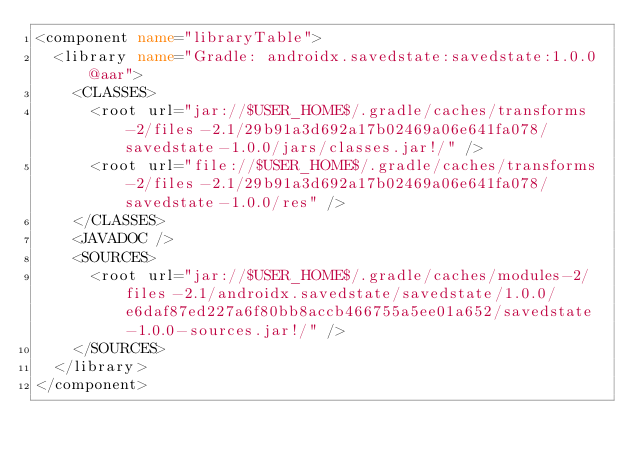<code> <loc_0><loc_0><loc_500><loc_500><_XML_><component name="libraryTable">
  <library name="Gradle: androidx.savedstate:savedstate:1.0.0@aar">
    <CLASSES>
      <root url="jar://$USER_HOME$/.gradle/caches/transforms-2/files-2.1/29b91a3d692a17b02469a06e641fa078/savedstate-1.0.0/jars/classes.jar!/" />
      <root url="file://$USER_HOME$/.gradle/caches/transforms-2/files-2.1/29b91a3d692a17b02469a06e641fa078/savedstate-1.0.0/res" />
    </CLASSES>
    <JAVADOC />
    <SOURCES>
      <root url="jar://$USER_HOME$/.gradle/caches/modules-2/files-2.1/androidx.savedstate/savedstate/1.0.0/e6daf87ed227a6f80bb8accb466755a5ee01a652/savedstate-1.0.0-sources.jar!/" />
    </SOURCES>
  </library>
</component></code> 